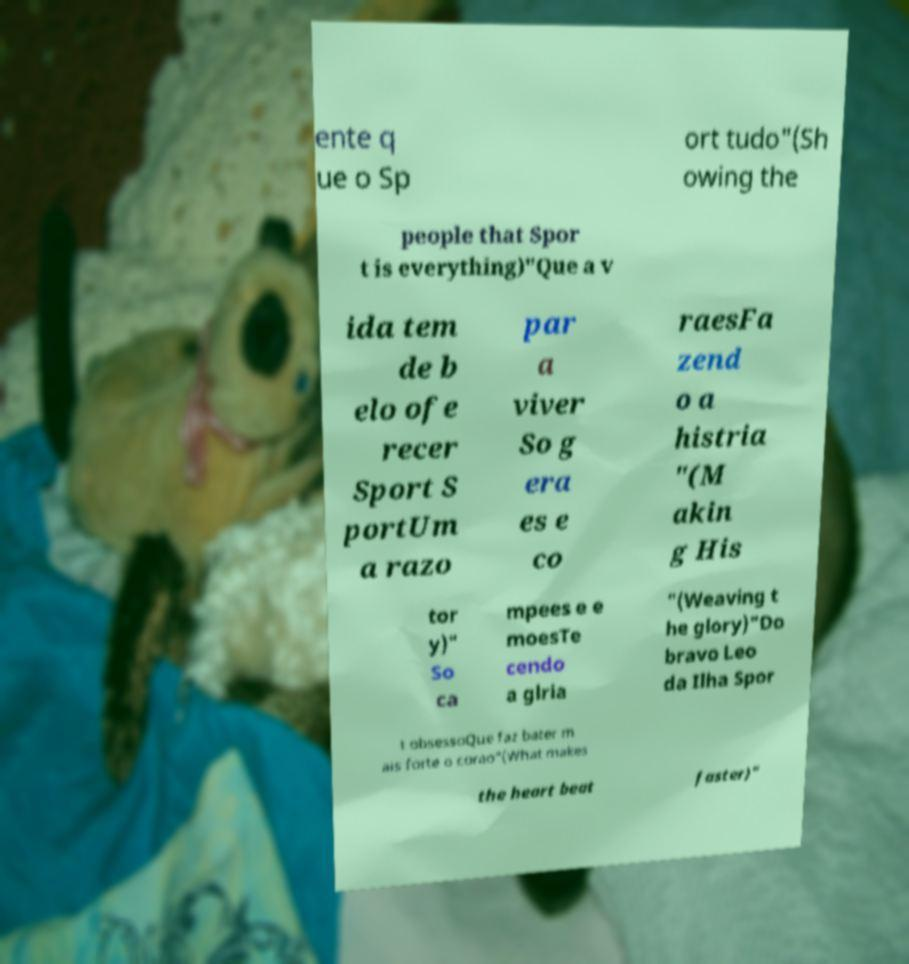Could you assist in decoding the text presented in this image and type it out clearly? ente q ue o Sp ort tudo"(Sh owing the people that Spor t is everything)"Que a v ida tem de b elo ofe recer Sport S portUm a razo par a viver So g era es e co raesFa zend o a histria "(M akin g His tor y)" So ca mpees e e moesTe cendo a glria "(Weaving t he glory)"Do bravo Leo da Ilha Spor t obsessoQue faz bater m ais forte o corao"(What makes the heart beat faster)" 